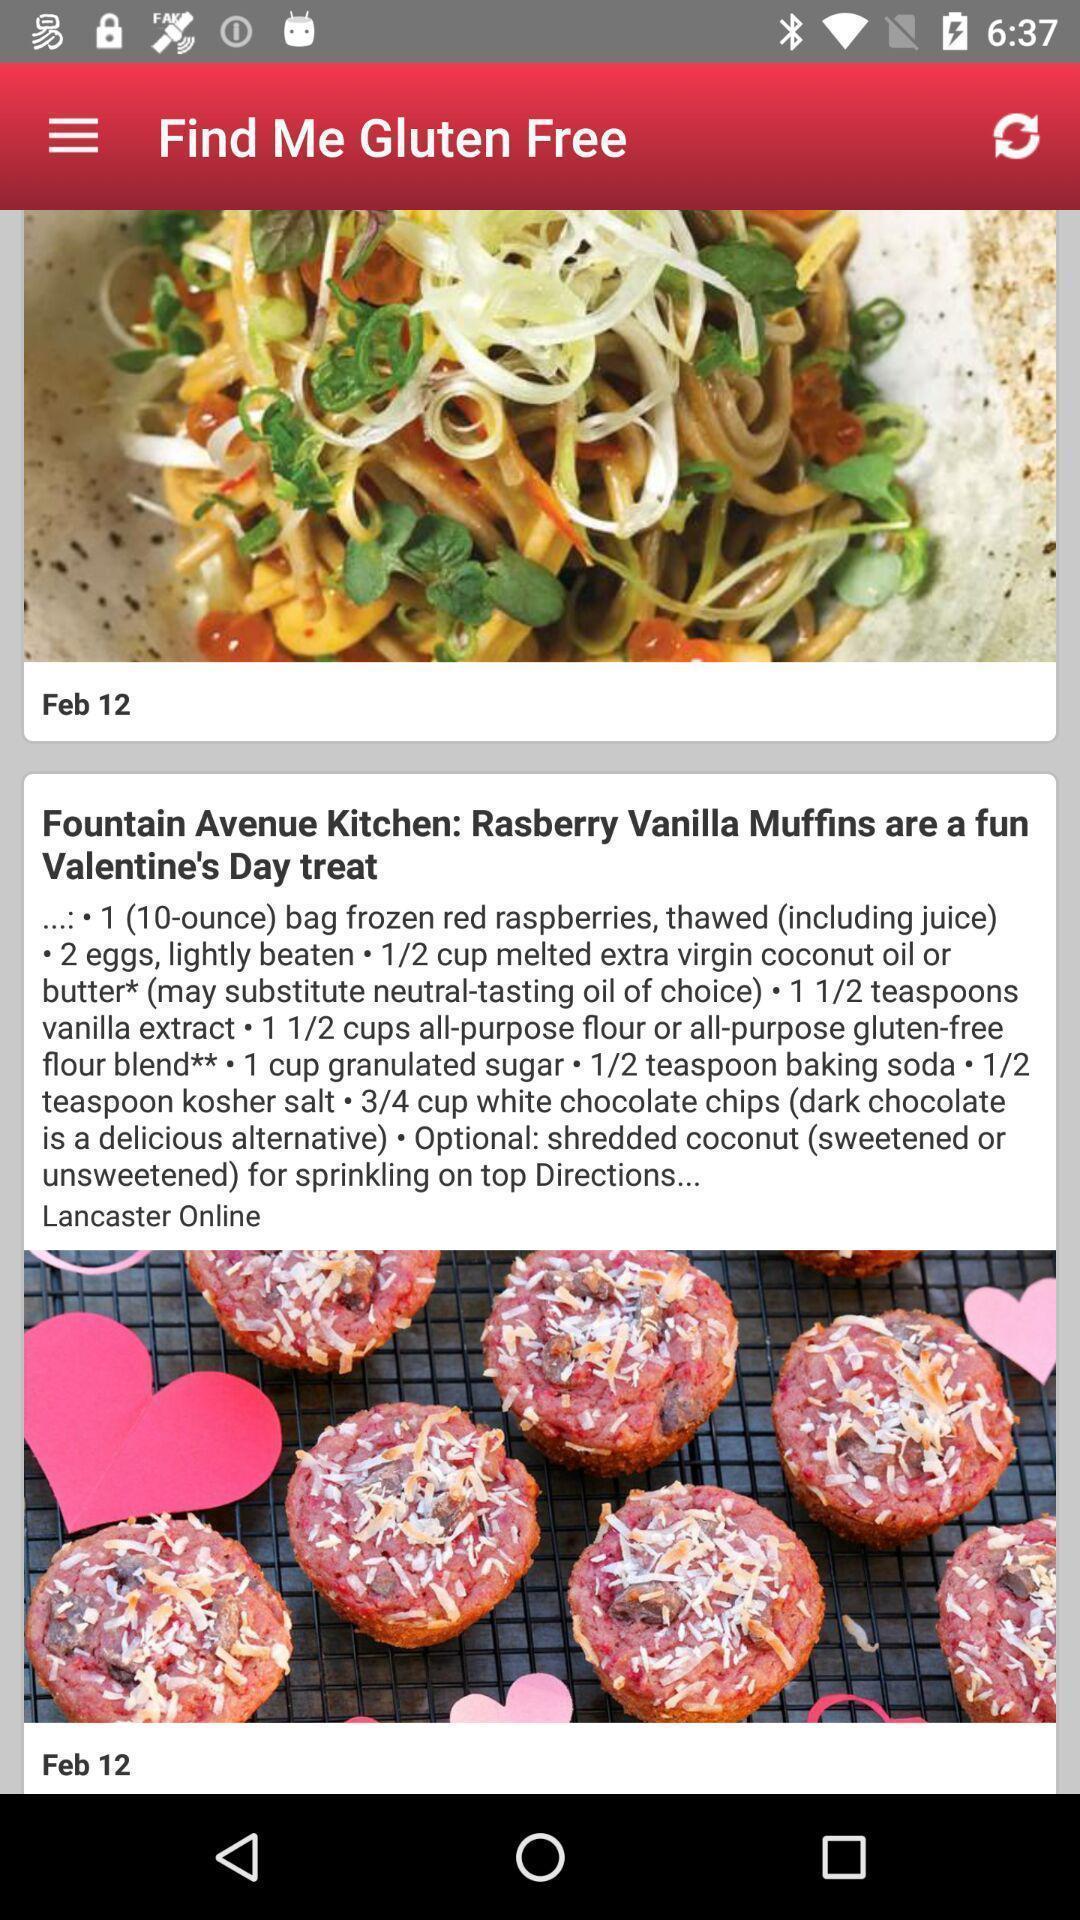Provide a description of this screenshot. Screen showing page. 